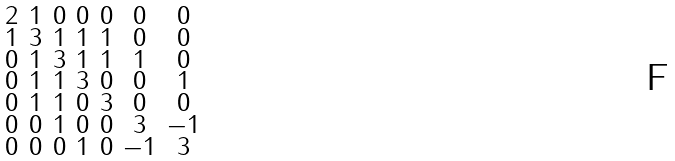<formula> <loc_0><loc_0><loc_500><loc_500>\begin{smallmatrix} 2 & 1 & 0 & 0 & 0 & 0 & 0 \\ 1 & 3 & 1 & 1 & 1 & 0 & 0 \\ 0 & 1 & 3 & 1 & 1 & 1 & 0 \\ 0 & 1 & 1 & 3 & 0 & 0 & 1 \\ 0 & 1 & 1 & 0 & 3 & 0 & 0 \\ 0 & 0 & 1 & 0 & 0 & 3 & - 1 \\ 0 & 0 & 0 & 1 & 0 & - 1 & 3 \end{smallmatrix}</formula> 